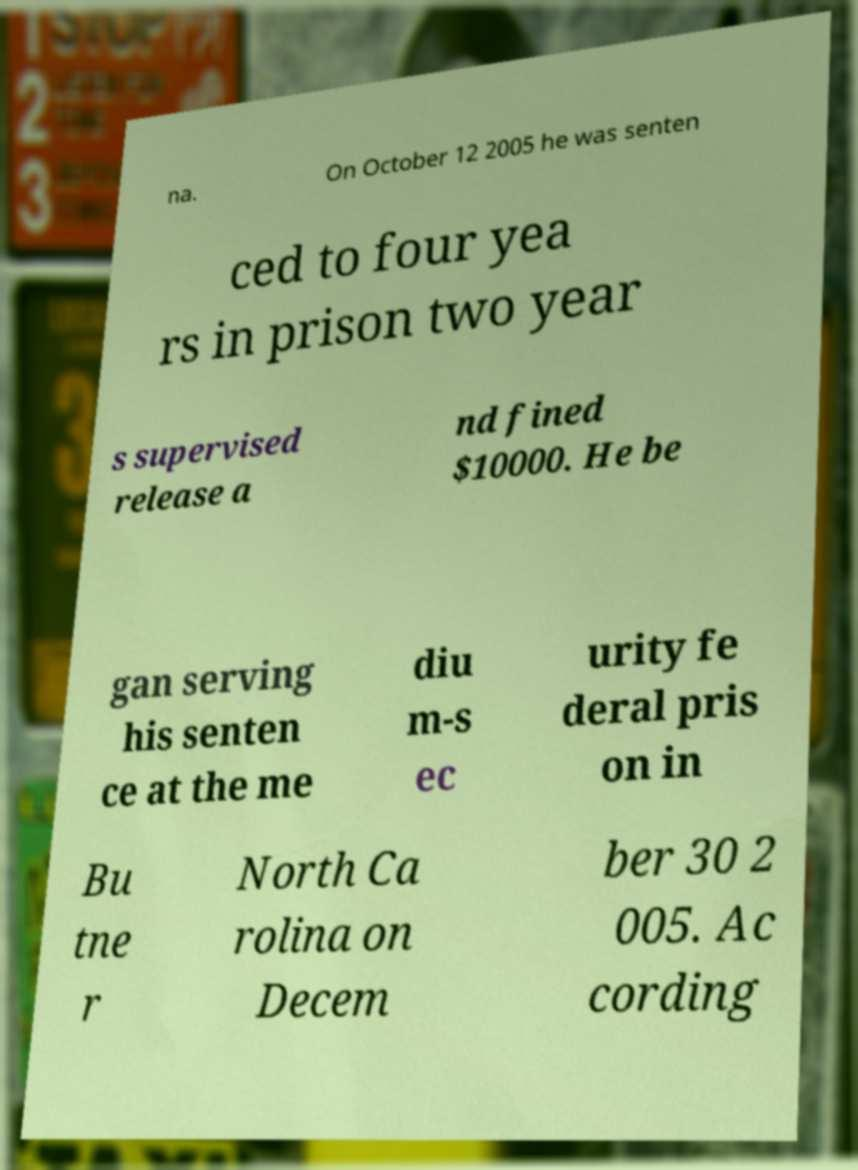Can you read and provide the text displayed in the image?This photo seems to have some interesting text. Can you extract and type it out for me? na. On October 12 2005 he was senten ced to four yea rs in prison two year s supervised release a nd fined $10000. He be gan serving his senten ce at the me diu m-s ec urity fe deral pris on in Bu tne r North Ca rolina on Decem ber 30 2 005. Ac cording 